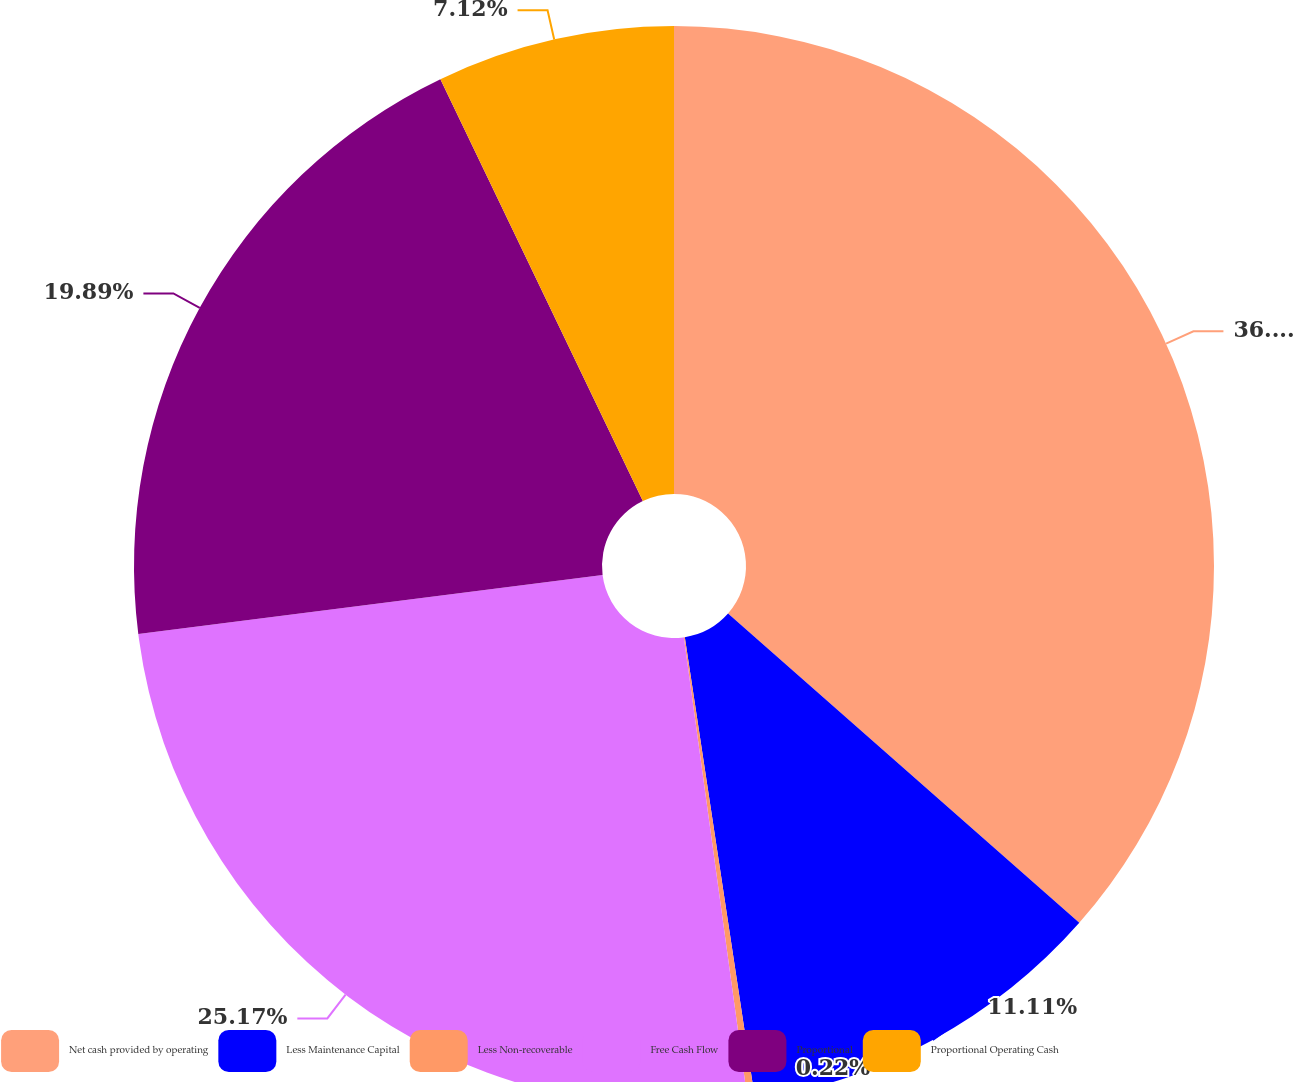Convert chart. <chart><loc_0><loc_0><loc_500><loc_500><pie_chart><fcel>Net cash provided by operating<fcel>Less Maintenance Capital<fcel>Less Non-recoverable<fcel>Free Cash Flow<fcel>Proportional<fcel>Proportional Operating Cash<nl><fcel>36.49%<fcel>11.11%<fcel>0.22%<fcel>25.17%<fcel>19.89%<fcel>7.12%<nl></chart> 